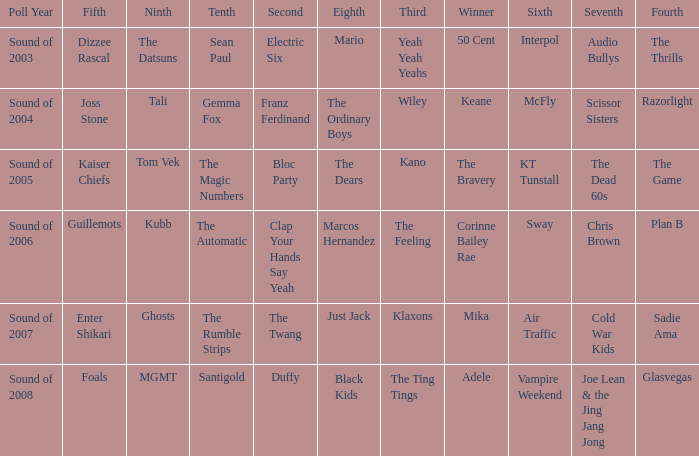Who was in 4th when in 6th is Air Traffic? Sadie Ama. 